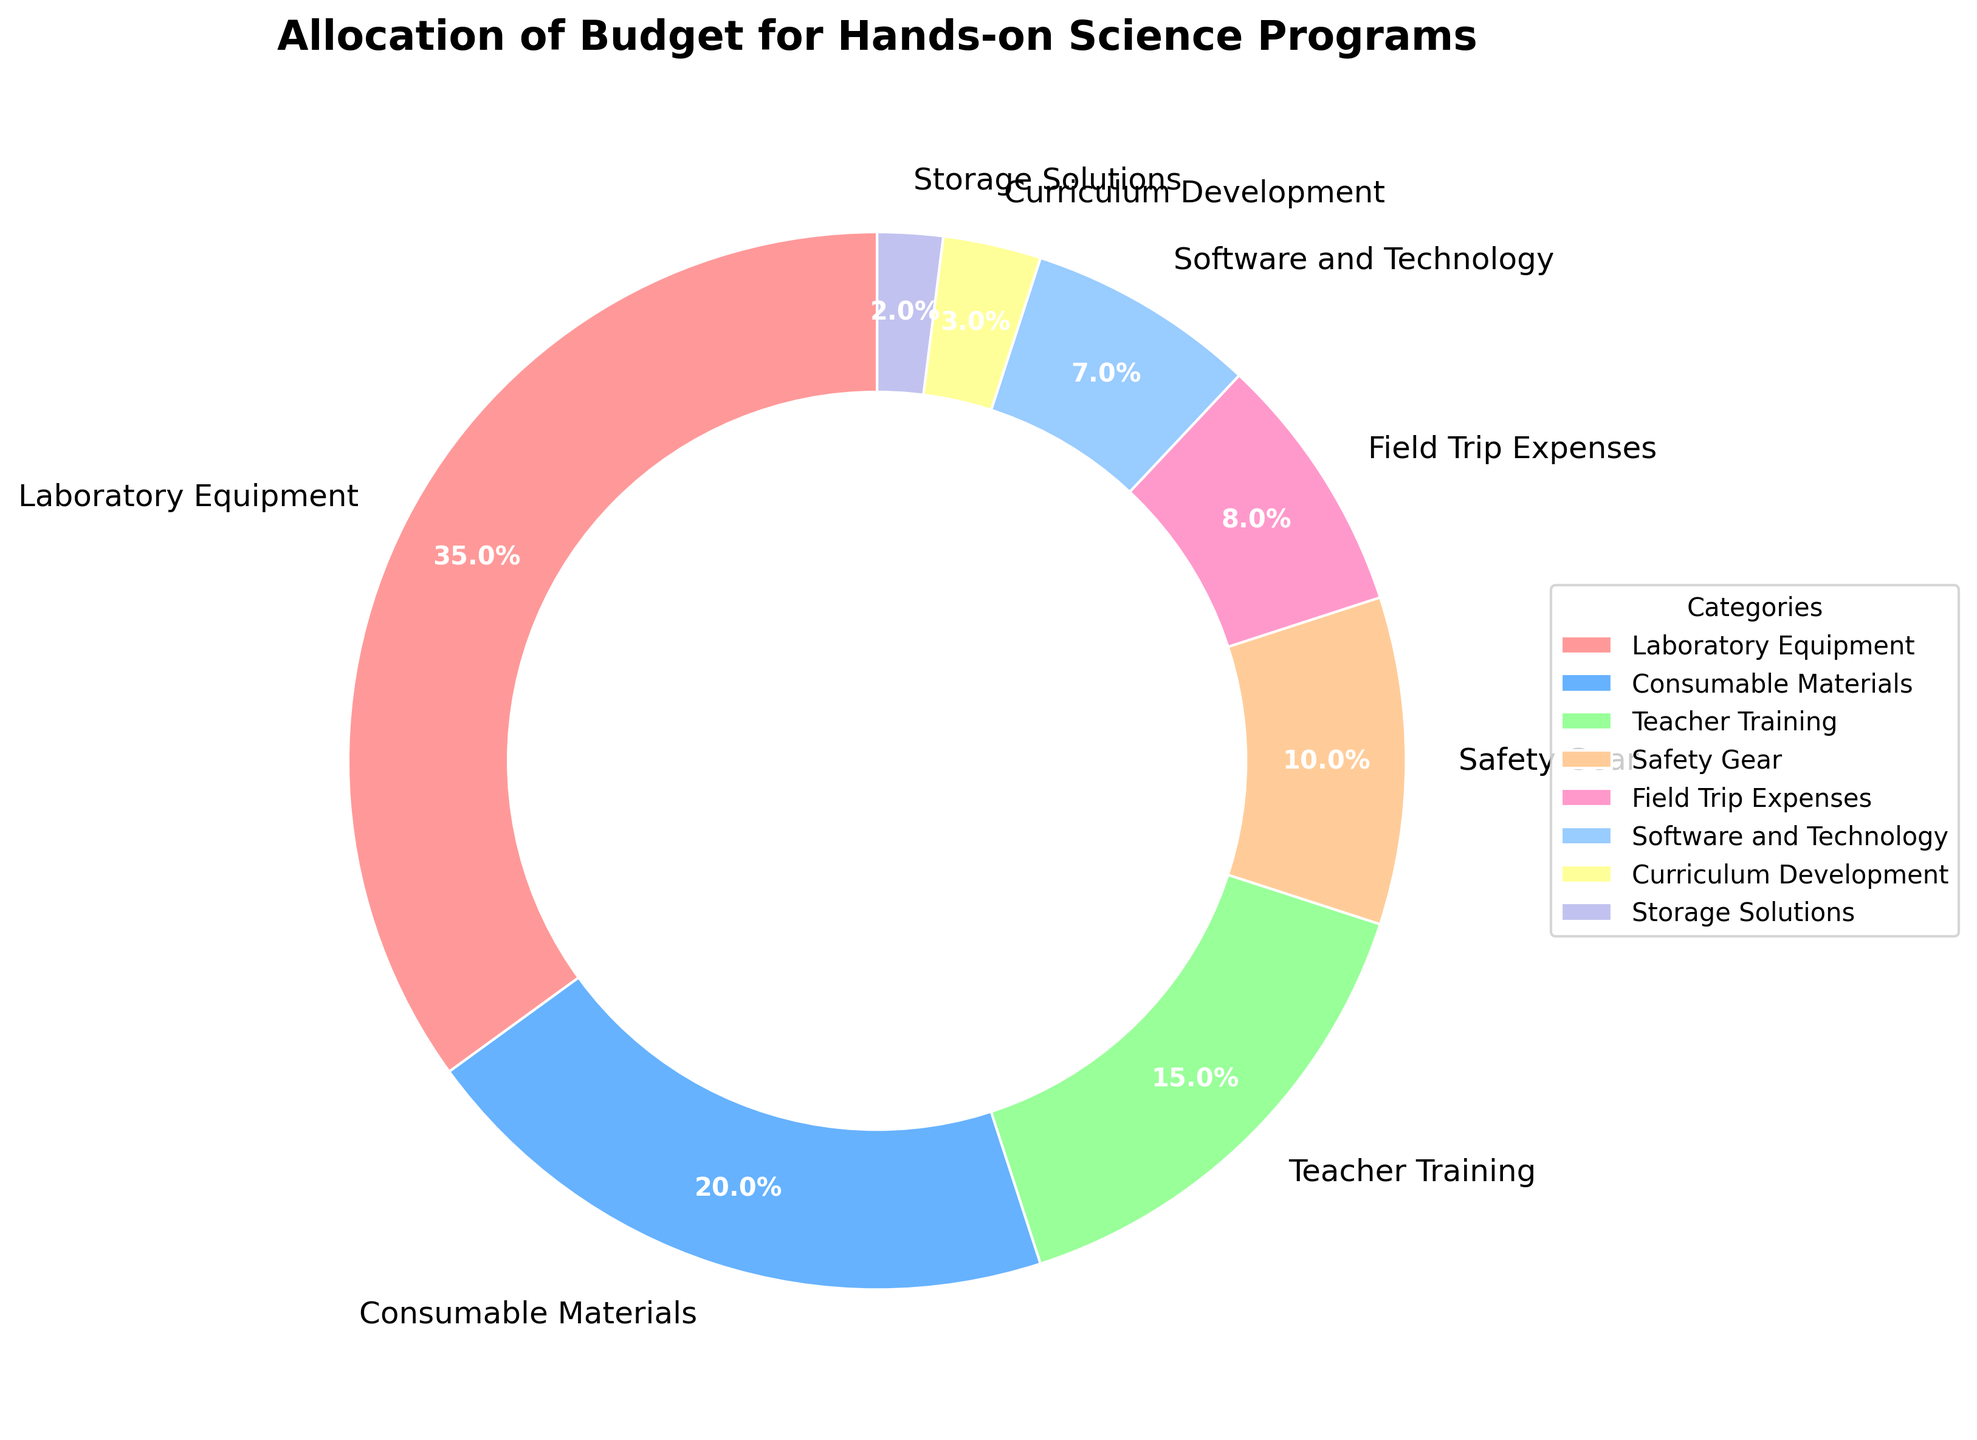What's the largest budget allocation category? The largest category is the one with the highest percentage. From the figure, "Laboratory Equipment" has the highest percentage at 35%.
Answer: Laboratory Equipment Which category has the smallest budget allocation? The smallest category is the one with the lowest percentage. From the figure, "Storage Solutions" has the lowest percentage at 2%.
Answer: Storage Solutions How much more is allocated to Laboratory Equipment compared to Software and Technology? Laboratory Equipment has 35% allocated, and Software and Technology has 7% allocated. The difference is 35% - 7% = 28%.
Answer: 28% What is the total percentage allocated to Consumable Materials and Field Trip Expenses combined? Consumable Materials is 20% and Field Trip Expenses is 8%, so the total combined percentage is 20% + 8% = 28%.
Answer: 28% If you combine the budget allocations for Teacher Training and Safety Gear, how does this compare to the allocation for Laboratory Equipment? Teacher Training is 15%, and Safety Gear is 10%. Combined, they are 15% + 10% = 25%. Laboratory Equipment is 35%. Comparing the two, 25% is less than 35%.
Answer: Less What is the difference in budget allocation between Consumable Materials and Teacher Training? Consumable Materials is allocated 20%, and Teacher Training is allocated 15%. The difference is 20% - 15% = 5%.
Answer: 5% Which category has a higher budget allocation: Safety Gear or Field Trip Expenses? Safety Gear has 10% allocated, and Field Trip Expenses have 8% allocated. So, Safety Gear has a higher allocation than Field Trip Expenses.
Answer: Safety Gear What is the total percentage allocated to categories related to technology (Software and Technology) and training (Teacher Training)? Software and Technology is 7% and Teacher Training is 15%. Combined, they are 7% + 15% = 22%.
Answer: 22% Which three categories have the highest budget allocations? The categories with the highest allocations are Laboratory Equipment (35%), Consumable Materials (20%), and Teacher Training (15%).
Answer: Laboratory Equipment, Consumable Materials, Teacher Training What percentage of the budget is allocated to categories other than Laboratory Equipment, Consumable Materials, and Teacher Training? The remaining categories are Safety Gear (10%), Field Trip Expenses (8%), Software and Technology (7%), Curriculum Development (3%), and Storage Solutions (2%). Summing these gives 10% + 8% + 7% + 3% + 2% = 30%.
Answer: 30% 